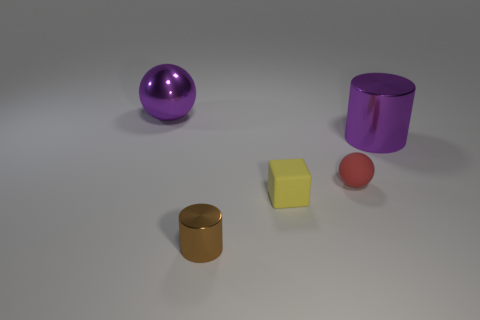Add 1 cylinders. How many objects exist? 6 Subtract all cubes. How many objects are left? 4 Add 5 small blue rubber cylinders. How many small blue rubber cylinders exist? 5 Subtract 0 yellow spheres. How many objects are left? 5 Subtract all large shiny things. Subtract all spheres. How many objects are left? 1 Add 1 matte blocks. How many matte blocks are left? 2 